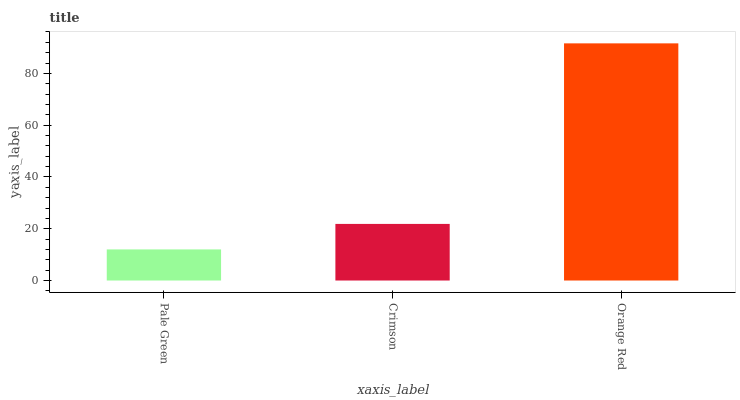Is Crimson the minimum?
Answer yes or no. No. Is Crimson the maximum?
Answer yes or no. No. Is Crimson greater than Pale Green?
Answer yes or no. Yes. Is Pale Green less than Crimson?
Answer yes or no. Yes. Is Pale Green greater than Crimson?
Answer yes or no. No. Is Crimson less than Pale Green?
Answer yes or no. No. Is Crimson the high median?
Answer yes or no. Yes. Is Crimson the low median?
Answer yes or no. Yes. Is Pale Green the high median?
Answer yes or no. No. Is Orange Red the low median?
Answer yes or no. No. 